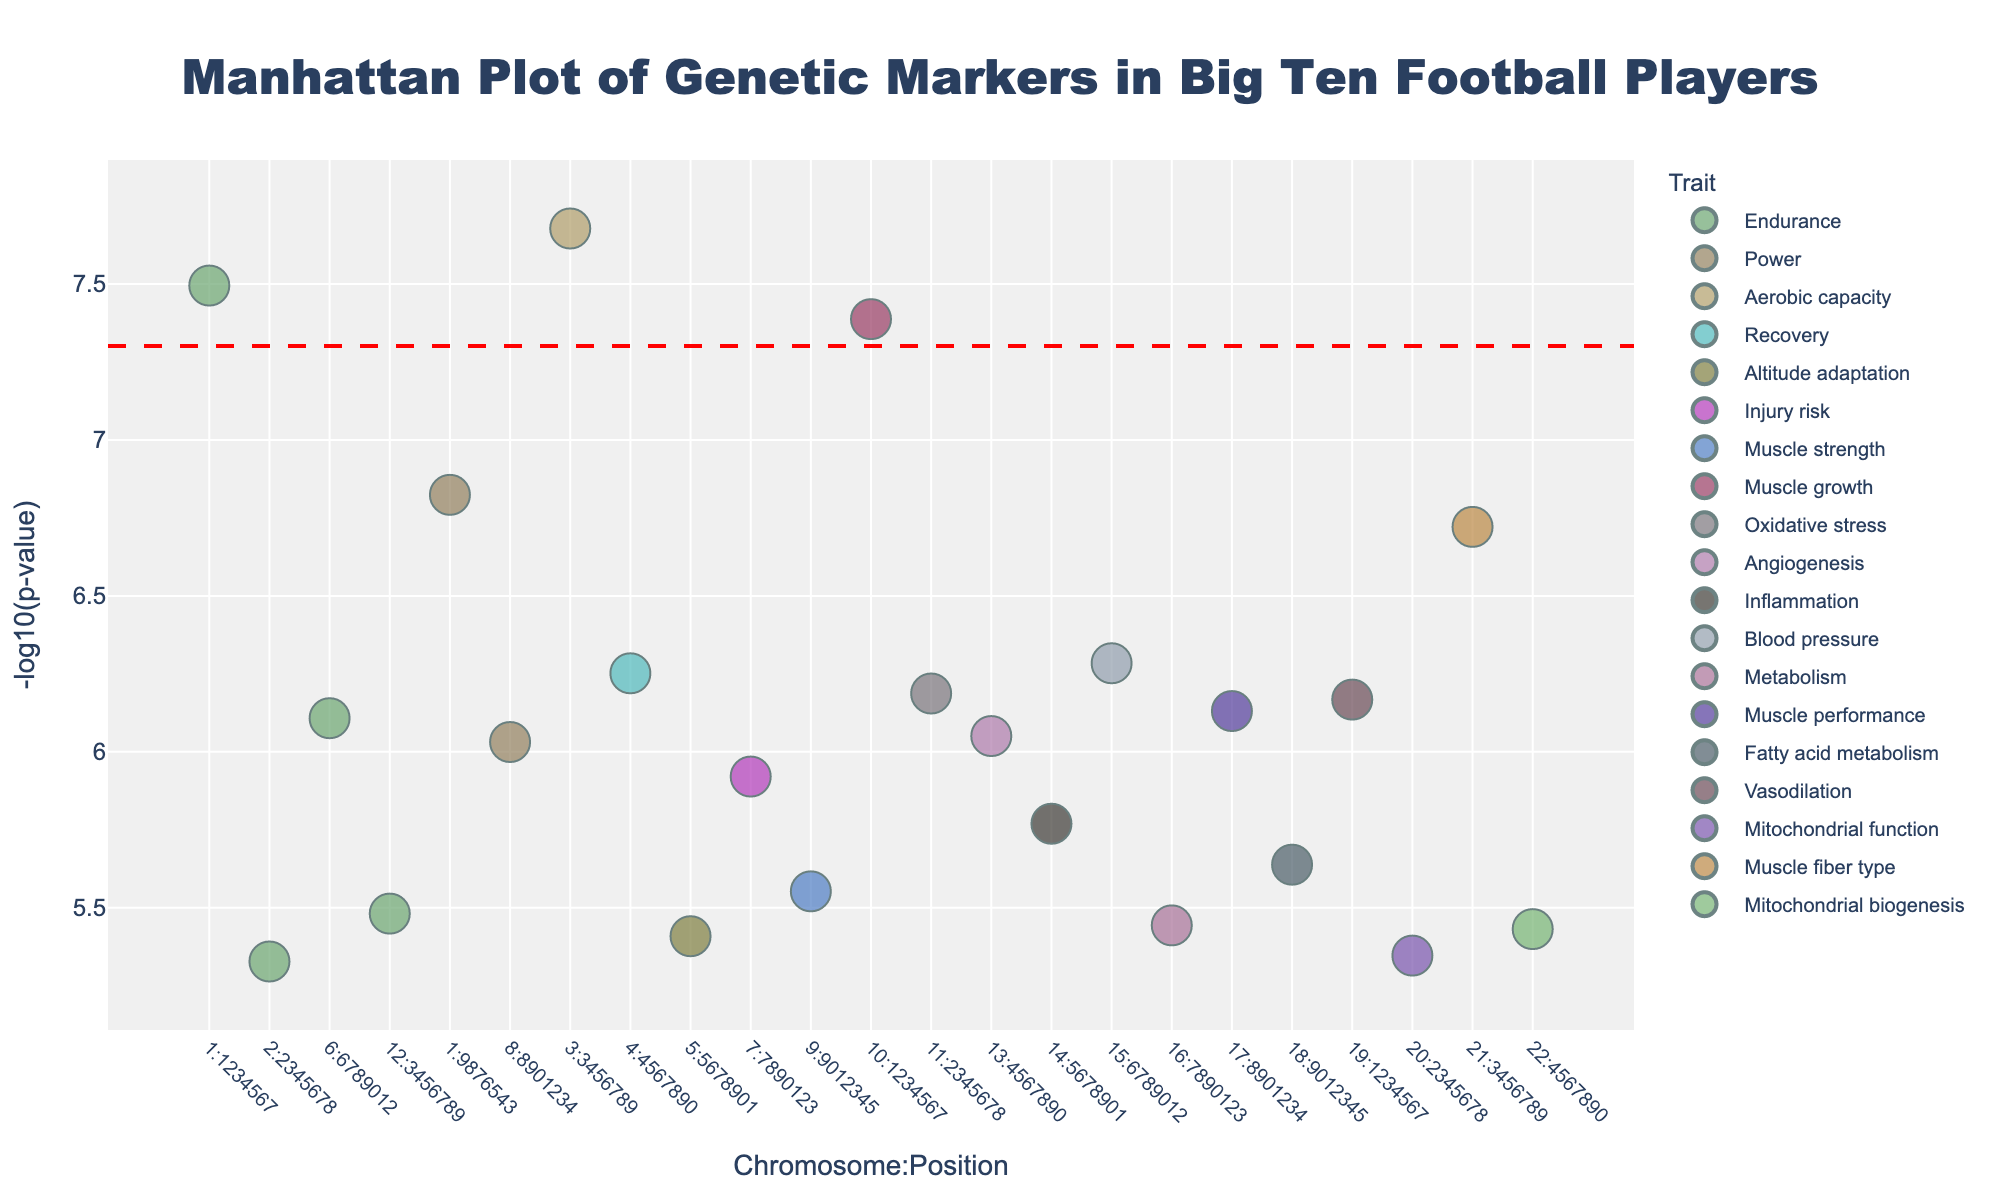What's the title of the plot? Look at the top of the figure to find the title. The title is a descriptive text that summarizes what the figure is about.
Answer: Manhattan Plot of Genetic Markers in Big Ten Football Players Which genetic marker is associated with the lowest p-value? Find the data point with the highest -log10(p-value) since a lower p-value corresponds to a higher -log10(p-value). Check the hover information for this highest value to find the gene name.
Answer: ACE How many traits have p-values below the threshold line? The threshold line is at -log10(p) = 7.28 (which is -log10(5e-8)). Count the number of data points above this line.
Answer: 3 Which trait is represented by the cluster of markers with the highest concentration of colors? Identify the group of markers with the most colors in a single cluster. Check the hover information for the trait names within this cluster.
Answer: Endurance What is the range of chromosome numbers shown in the plot? Look at the x-axis to find the smallest and largest chromosome numbers.
Answer: 1 to 22 Which gene has the largest marker size and what is its associated trait? The marker size is proportional to the -log10(p-value). Find the largest marker and note its gene and trait information from the hover text.
Answer: ACTN3, Power Compare the -log10(p-value) of the genes ADRB2 and NRF2. Which one is higher? Find the -log10(p-values) for both genes ADRB2 and NRF2 and compare the values.
Answer: ADRB2 What is the average -log10(p) value for genes associated with Endurance? List the -log10(p-values) for all markers with the trait 'Endurance' and calculate their average.
Answer: (7.49 + 5.33 + 6.71 + 5.48 + 5.32) / 5 = 5.91 Which chromosome has the gene with the lowest p-value after Chromosome 1? Exclude Chromosome 1 and find the next highest -log10(p-value). Note the associated chromosome and gene.
Answer: Chromosome 3, EPOR 